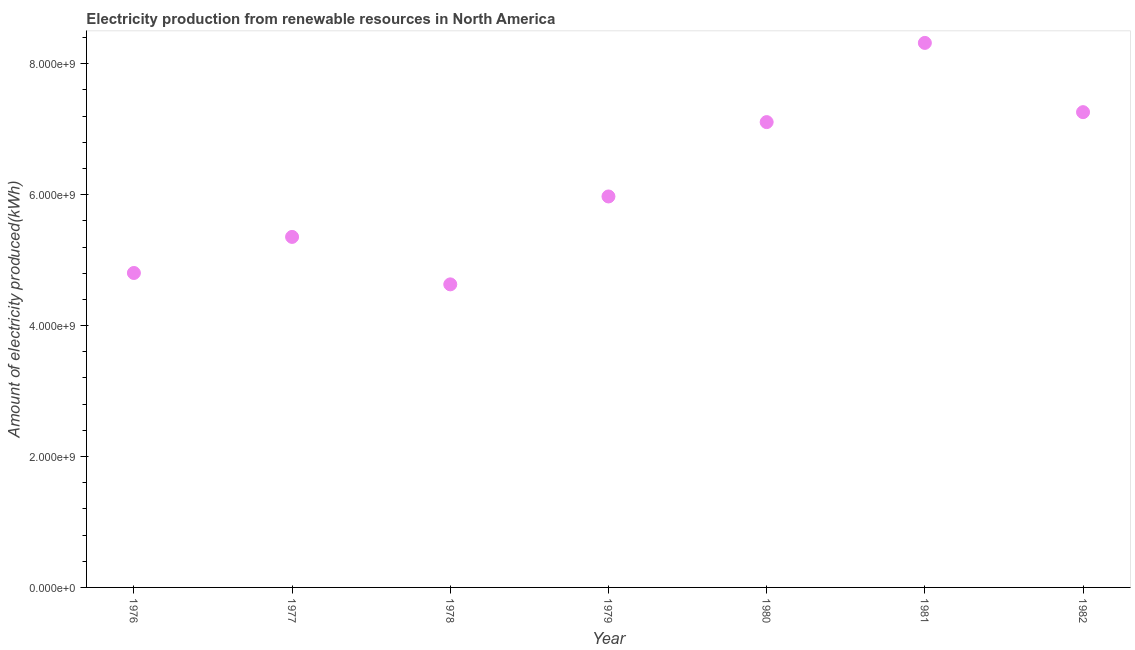What is the amount of electricity produced in 1982?
Offer a terse response. 7.26e+09. Across all years, what is the maximum amount of electricity produced?
Your answer should be compact. 8.32e+09. Across all years, what is the minimum amount of electricity produced?
Offer a terse response. 4.63e+09. In which year was the amount of electricity produced minimum?
Offer a very short reply. 1978. What is the sum of the amount of electricity produced?
Offer a terse response. 4.35e+1. What is the difference between the amount of electricity produced in 1976 and 1982?
Make the answer very short. -2.46e+09. What is the average amount of electricity produced per year?
Your response must be concise. 6.21e+09. What is the median amount of electricity produced?
Your response must be concise. 5.97e+09. What is the ratio of the amount of electricity produced in 1976 to that in 1982?
Offer a terse response. 0.66. What is the difference between the highest and the second highest amount of electricity produced?
Offer a terse response. 1.06e+09. Is the sum of the amount of electricity produced in 1981 and 1982 greater than the maximum amount of electricity produced across all years?
Provide a short and direct response. Yes. What is the difference between the highest and the lowest amount of electricity produced?
Your response must be concise. 3.69e+09. In how many years, is the amount of electricity produced greater than the average amount of electricity produced taken over all years?
Keep it short and to the point. 3. Does the amount of electricity produced monotonically increase over the years?
Your answer should be very brief. No. How many dotlines are there?
Your answer should be very brief. 1. Does the graph contain any zero values?
Ensure brevity in your answer.  No. What is the title of the graph?
Give a very brief answer. Electricity production from renewable resources in North America. What is the label or title of the X-axis?
Your answer should be compact. Year. What is the label or title of the Y-axis?
Your answer should be very brief. Amount of electricity produced(kWh). What is the Amount of electricity produced(kWh) in 1976?
Provide a succinct answer. 4.80e+09. What is the Amount of electricity produced(kWh) in 1977?
Give a very brief answer. 5.36e+09. What is the Amount of electricity produced(kWh) in 1978?
Ensure brevity in your answer.  4.63e+09. What is the Amount of electricity produced(kWh) in 1979?
Your response must be concise. 5.97e+09. What is the Amount of electricity produced(kWh) in 1980?
Your response must be concise. 7.11e+09. What is the Amount of electricity produced(kWh) in 1981?
Your answer should be very brief. 8.32e+09. What is the Amount of electricity produced(kWh) in 1982?
Your answer should be compact. 7.26e+09. What is the difference between the Amount of electricity produced(kWh) in 1976 and 1977?
Keep it short and to the point. -5.51e+08. What is the difference between the Amount of electricity produced(kWh) in 1976 and 1978?
Your response must be concise. 1.74e+08. What is the difference between the Amount of electricity produced(kWh) in 1976 and 1979?
Provide a succinct answer. -1.17e+09. What is the difference between the Amount of electricity produced(kWh) in 1976 and 1980?
Ensure brevity in your answer.  -2.30e+09. What is the difference between the Amount of electricity produced(kWh) in 1976 and 1981?
Provide a succinct answer. -3.52e+09. What is the difference between the Amount of electricity produced(kWh) in 1976 and 1982?
Your answer should be very brief. -2.46e+09. What is the difference between the Amount of electricity produced(kWh) in 1977 and 1978?
Offer a very short reply. 7.25e+08. What is the difference between the Amount of electricity produced(kWh) in 1977 and 1979?
Your answer should be very brief. -6.18e+08. What is the difference between the Amount of electricity produced(kWh) in 1977 and 1980?
Your response must be concise. -1.75e+09. What is the difference between the Amount of electricity produced(kWh) in 1977 and 1981?
Your answer should be very brief. -2.96e+09. What is the difference between the Amount of electricity produced(kWh) in 1977 and 1982?
Your answer should be compact. -1.91e+09. What is the difference between the Amount of electricity produced(kWh) in 1978 and 1979?
Give a very brief answer. -1.34e+09. What is the difference between the Amount of electricity produced(kWh) in 1978 and 1980?
Give a very brief answer. -2.48e+09. What is the difference between the Amount of electricity produced(kWh) in 1978 and 1981?
Keep it short and to the point. -3.69e+09. What is the difference between the Amount of electricity produced(kWh) in 1978 and 1982?
Provide a short and direct response. -2.63e+09. What is the difference between the Amount of electricity produced(kWh) in 1979 and 1980?
Your response must be concise. -1.14e+09. What is the difference between the Amount of electricity produced(kWh) in 1979 and 1981?
Provide a succinct answer. -2.35e+09. What is the difference between the Amount of electricity produced(kWh) in 1979 and 1982?
Keep it short and to the point. -1.29e+09. What is the difference between the Amount of electricity produced(kWh) in 1980 and 1981?
Your response must be concise. -1.21e+09. What is the difference between the Amount of electricity produced(kWh) in 1980 and 1982?
Offer a terse response. -1.52e+08. What is the difference between the Amount of electricity produced(kWh) in 1981 and 1982?
Make the answer very short. 1.06e+09. What is the ratio of the Amount of electricity produced(kWh) in 1976 to that in 1977?
Your answer should be very brief. 0.9. What is the ratio of the Amount of electricity produced(kWh) in 1976 to that in 1978?
Your response must be concise. 1.04. What is the ratio of the Amount of electricity produced(kWh) in 1976 to that in 1979?
Provide a succinct answer. 0.8. What is the ratio of the Amount of electricity produced(kWh) in 1976 to that in 1980?
Your response must be concise. 0.68. What is the ratio of the Amount of electricity produced(kWh) in 1976 to that in 1981?
Keep it short and to the point. 0.58. What is the ratio of the Amount of electricity produced(kWh) in 1976 to that in 1982?
Give a very brief answer. 0.66. What is the ratio of the Amount of electricity produced(kWh) in 1977 to that in 1978?
Your response must be concise. 1.16. What is the ratio of the Amount of electricity produced(kWh) in 1977 to that in 1979?
Provide a short and direct response. 0.9. What is the ratio of the Amount of electricity produced(kWh) in 1977 to that in 1980?
Keep it short and to the point. 0.75. What is the ratio of the Amount of electricity produced(kWh) in 1977 to that in 1981?
Provide a succinct answer. 0.64. What is the ratio of the Amount of electricity produced(kWh) in 1977 to that in 1982?
Provide a short and direct response. 0.74. What is the ratio of the Amount of electricity produced(kWh) in 1978 to that in 1979?
Keep it short and to the point. 0.78. What is the ratio of the Amount of electricity produced(kWh) in 1978 to that in 1980?
Ensure brevity in your answer.  0.65. What is the ratio of the Amount of electricity produced(kWh) in 1978 to that in 1981?
Give a very brief answer. 0.56. What is the ratio of the Amount of electricity produced(kWh) in 1978 to that in 1982?
Your response must be concise. 0.64. What is the ratio of the Amount of electricity produced(kWh) in 1979 to that in 1980?
Your answer should be compact. 0.84. What is the ratio of the Amount of electricity produced(kWh) in 1979 to that in 1981?
Your response must be concise. 0.72. What is the ratio of the Amount of electricity produced(kWh) in 1979 to that in 1982?
Make the answer very short. 0.82. What is the ratio of the Amount of electricity produced(kWh) in 1980 to that in 1981?
Keep it short and to the point. 0.85. What is the ratio of the Amount of electricity produced(kWh) in 1981 to that in 1982?
Give a very brief answer. 1.15. 